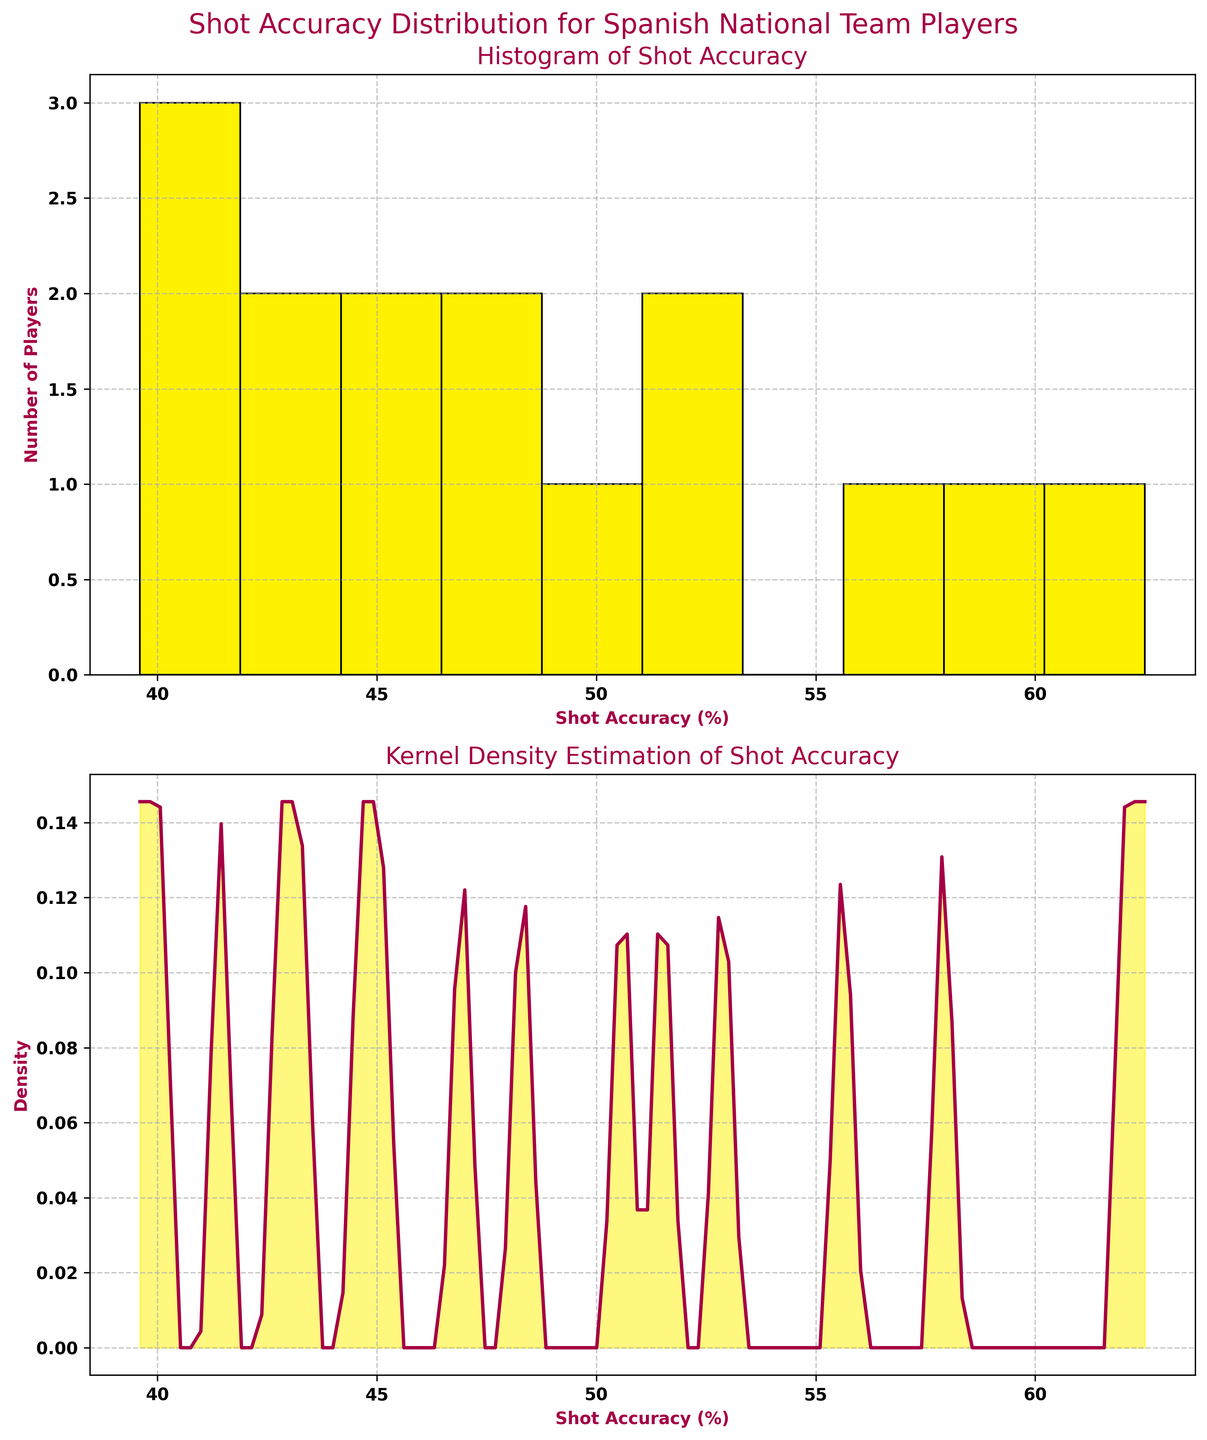What's the title of the figure? The title is at the top of the figure and clearly states the topic.
Answer: Shot Accuracy Distribution for Spanish National Team Players How many players have a shot accuracy above 50%? You need to count the bars in the histogram that have their right edge beyond the 50% mark.
Answer: 6 What is the range of shot accuracy percentages in the data? The range is from the lowest to the highest shot accuracy shown on the x-axis of the plots.
Answer: 39.6% to 62.5% Which player has the lowest shot accuracy? You can identify the player with the lowest shot accuracy from the original data provided.
Answer: Cesar Azpilicueta How many bins are used in the histogram? Count the number of bars in the histogram subplot.
Answer: 10 What is the density value for a shot accuracy of 50% in the KDE plot? Find the 50% mark on the x-axis in the KDE plot and look at the corresponding y-value (density).
Answer: Approximately 0.06 Which subplot shows the distribution in a smoother way? Compare the visual appearance of the two subplots, where one is a histogram and the other is a KDE plot.
Answer: KDE plot How many players have shot accuracies between 45% and 55%? Count the number of players whose shot accuracy lies within the interval [45%, 55%] using the histogram or KDE plot.
Answer: 5 Is there any player with a shot accuracy exactly matching the lowest bin in the histogram? Check the data used to generate the figure and match the values to the bar edges in the histogram.
Answer: No Which player has the highest shot accuracy? Identify the player with the highest shot accuracy from the original data provided.
Answer: Alvaro Morata 